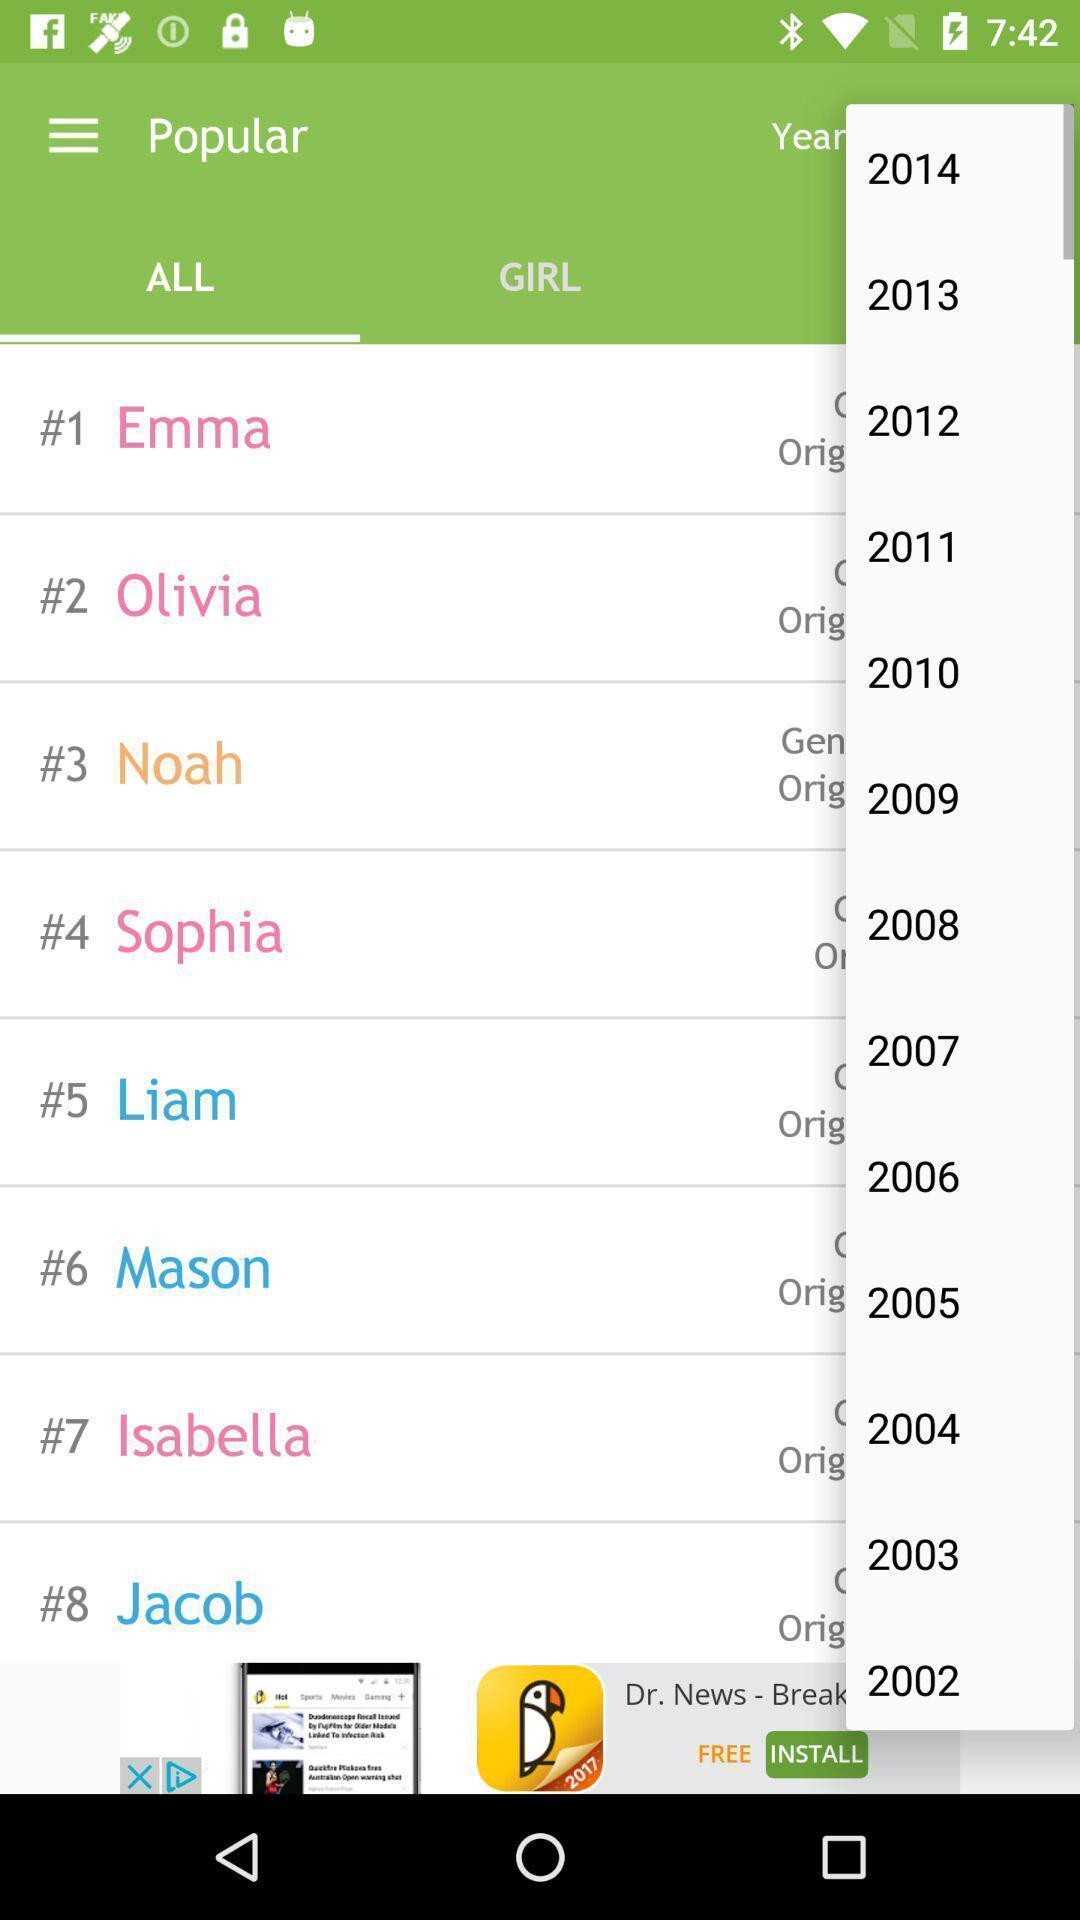Give me a summary of this screen capture. Pop up displaying list of years on an app. 